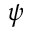<formula> <loc_0><loc_0><loc_500><loc_500>\psi</formula> 